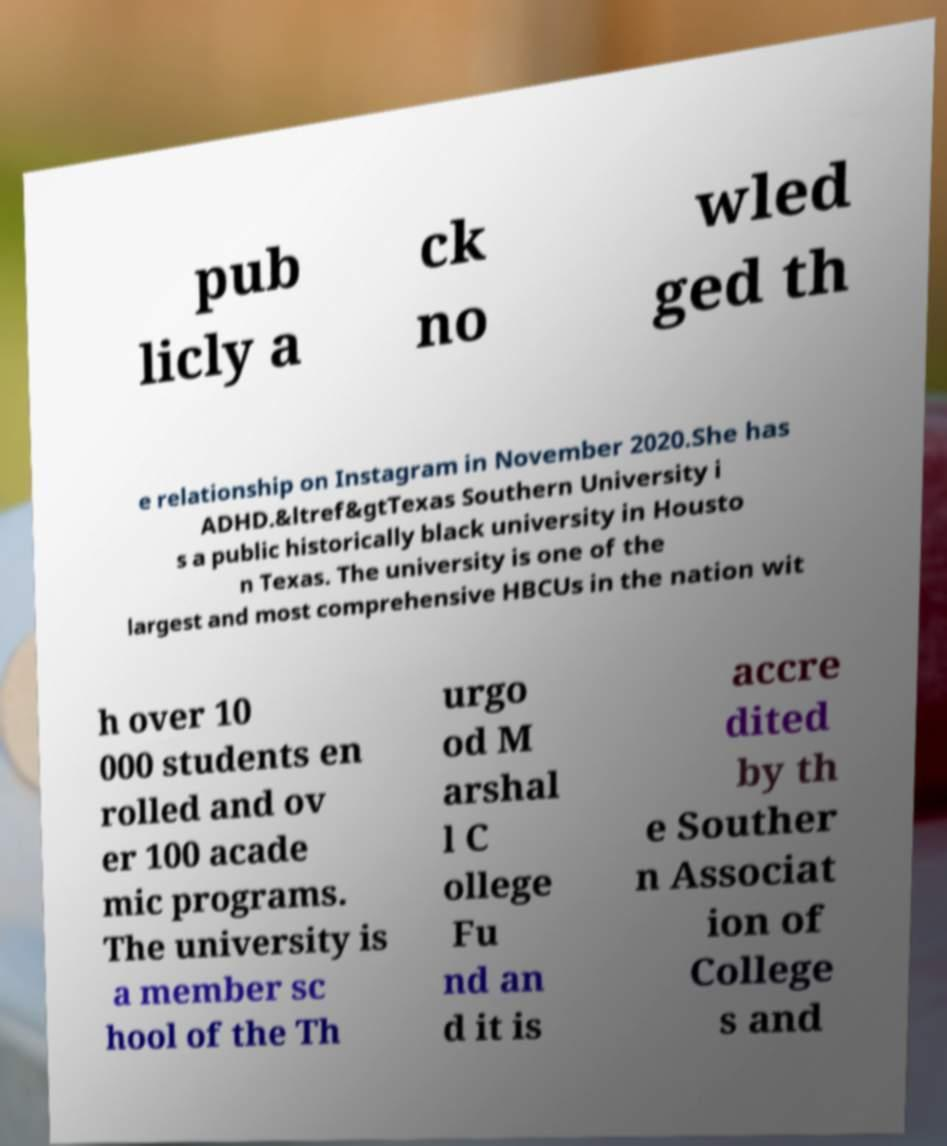Could you extract and type out the text from this image? pub licly a ck no wled ged th e relationship on Instagram in November 2020.She has ADHD.&ltref&gtTexas Southern University i s a public historically black university in Housto n Texas. The university is one of the largest and most comprehensive HBCUs in the nation wit h over 10 000 students en rolled and ov er 100 acade mic programs. The university is a member sc hool of the Th urgo od M arshal l C ollege Fu nd an d it is accre dited by th e Souther n Associat ion of College s and 